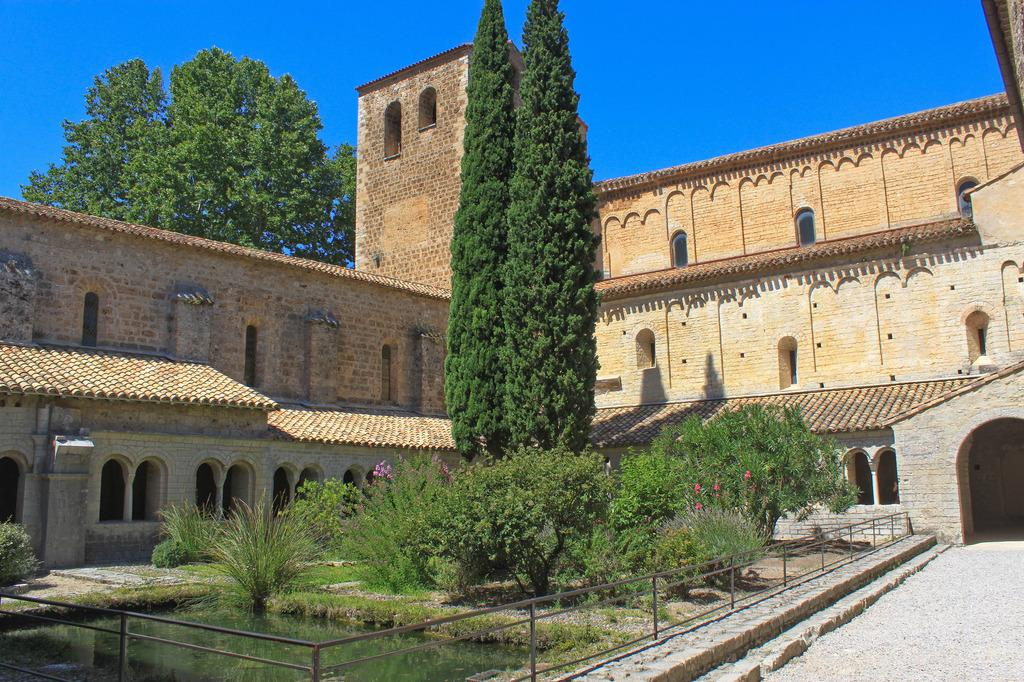What type of structures can be seen in the image? There are buildings in the image. What natural elements are present in the image? There are trees and a pond in the image. What type of vegetation can be seen in the image? There are plants in the image. What type of surface is visible in the image? There are pavements in the image. What type of barrier is present in the image? There are railings in the image. What part of the natural environment is visible in the image? The sky is visible in the image. How many apples are hanging from the trees in the image? There are no apples present in the image; only trees are visible. What grade is the building in the image? The provided facts do not mention the grade or any other architectural details of the building. 